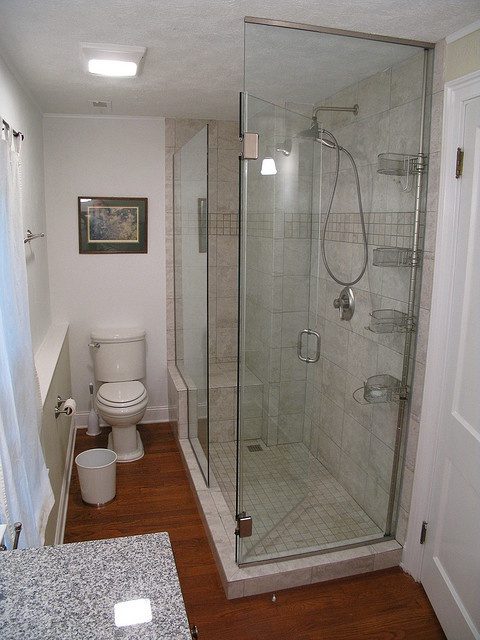Describe the objects in this image and their specific colors. I can see a toilet in gray and darkgray tones in this image. 